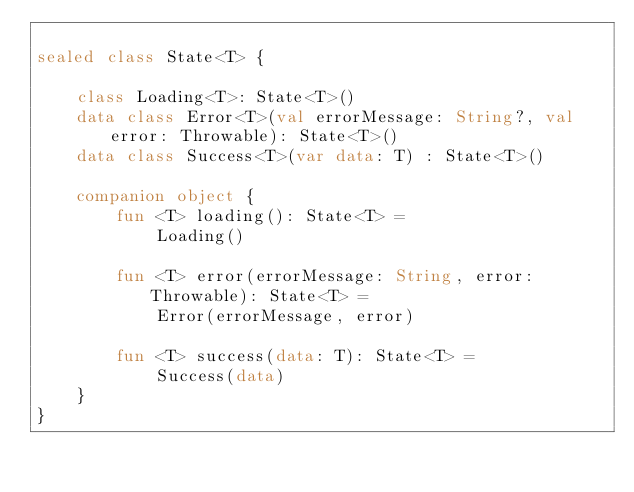Convert code to text. <code><loc_0><loc_0><loc_500><loc_500><_Kotlin_>
sealed class State<T> {

    class Loading<T>: State<T>()
    data class Error<T>(val errorMessage: String?, val error: Throwable): State<T>()
    data class Success<T>(var data: T) : State<T>()

    companion object {
        fun <T> loading(): State<T> =
            Loading()

        fun <T> error(errorMessage: String, error: Throwable): State<T> =
            Error(errorMessage, error)

        fun <T> success(data: T): State<T> =
            Success(data)
    }
}</code> 